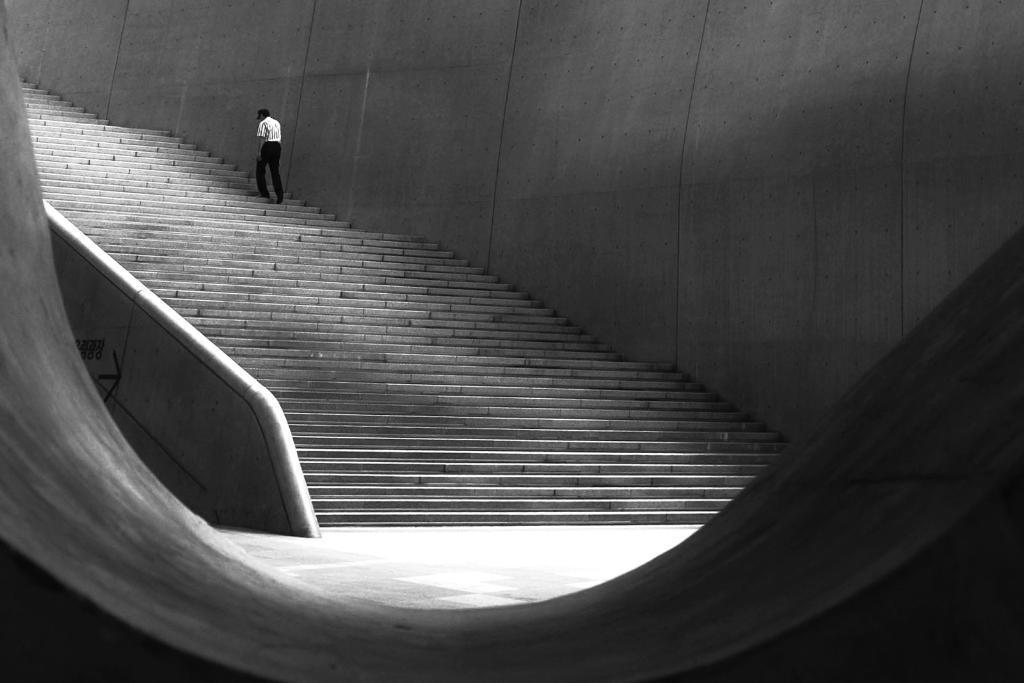In one or two sentences, can you explain what this image depicts? In this image there is a person visible on the steps, beside the person there is the wall. 